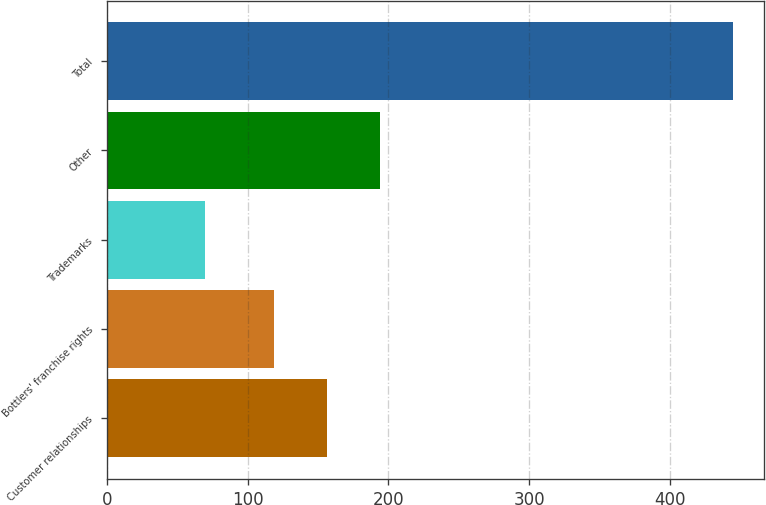<chart> <loc_0><loc_0><loc_500><loc_500><bar_chart><fcel>Customer relationships<fcel>Bottlers' franchise rights<fcel>Trademarks<fcel>Other<fcel>Total<nl><fcel>156.5<fcel>119<fcel>70<fcel>194<fcel>445<nl></chart> 